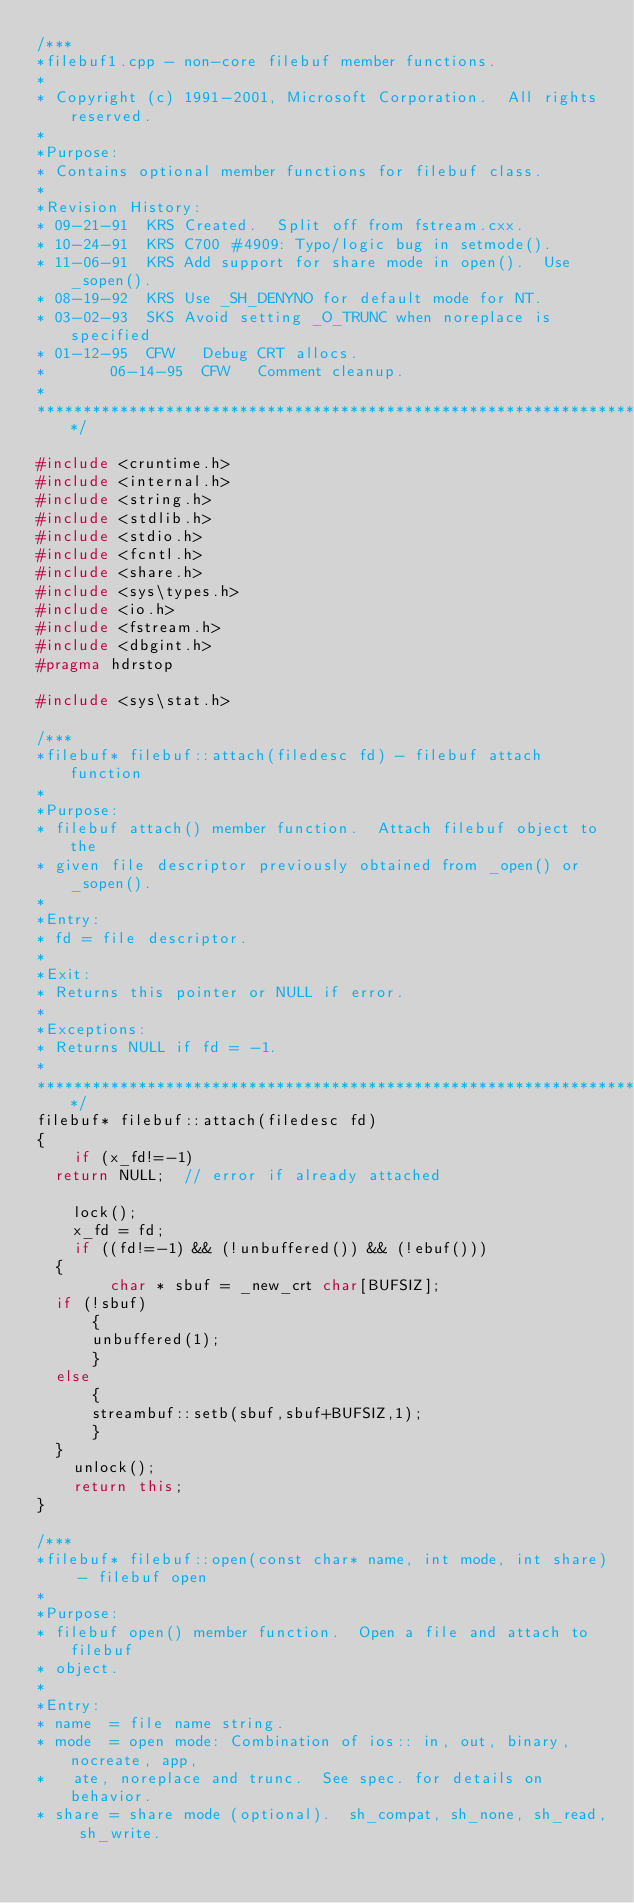<code> <loc_0><loc_0><loc_500><loc_500><_C++_>/***
*filebuf1.cpp - non-core filebuf member functions.
*
*	Copyright (c) 1991-2001, Microsoft Corporation.  All rights reserved.
*
*Purpose:
*	Contains optional member functions for filebuf class.
*
*Revision History:
*	09-21-91  KRS	Created.  Split off from fstream.cxx.
*	10-24-91  KRS	C700 #4909: Typo/logic bug in setmode().
*	11-06-91  KRS	Add support for share mode in open().  Use _sopen().
*	08-19-92  KRS	Use _SH_DENYNO for default mode for NT.
*	03-02-93  SKS	Avoid setting _O_TRUNC when noreplace is specified
*	01-12-95  CFW   Debug CRT allocs.
*       06-14-95  CFW   Comment cleanup.
*
*******************************************************************************/

#include <cruntime.h>
#include <internal.h>
#include <string.h>
#include <stdlib.h>
#include <stdio.h>
#include <fcntl.h>
#include <share.h>
#include <sys\types.h>
#include <io.h>
#include <fstream.h>
#include <dbgint.h>
#pragma hdrstop

#include <sys\stat.h>

/***
*filebuf* filebuf::attach(filedesc fd) - filebuf attach function
*
*Purpose:
*	filebuf attach() member function.  Attach filebuf object to the
*	given file descriptor previously obtained from _open() or _sopen().
*
*Entry:
*	fd = file descriptor.
*
*Exit:
*	Returns this pointer or NULL if error.
*
*Exceptions:
*	Returns NULL if fd = -1.
*
*******************************************************************************/
filebuf* filebuf::attach(filedesc fd)
{
    if (x_fd!=-1)
	return NULL;	// error if already attached

    lock();
    x_fd = fd;
    if ((fd!=-1) && (!unbuffered()) && (!ebuf()))
	{
        char * sbuf = _new_crt char[BUFSIZ];
	if (!sbuf)
	    {
	    unbuffered(1);
	    }
	else
	    {
	    streambuf::setb(sbuf,sbuf+BUFSIZ,1);
	    }
	}
    unlock();
    return this; 
}

/***
*filebuf* filebuf::open(const char* name, int mode, int share) - filebuf open
*
*Purpose:
*	filebuf open() member function.  Open a file and attach to filebuf
*	object.
*
*Entry:
*	name  = file name string.
*	mode  = open mode: Combination of ios:: in, out, binary, nocreate, app,
*		ate, noreplace and trunc.  See spec. for details on behavior.
*	share = share mode (optional).  sh_compat, sh_none, sh_read, sh_write.</code> 